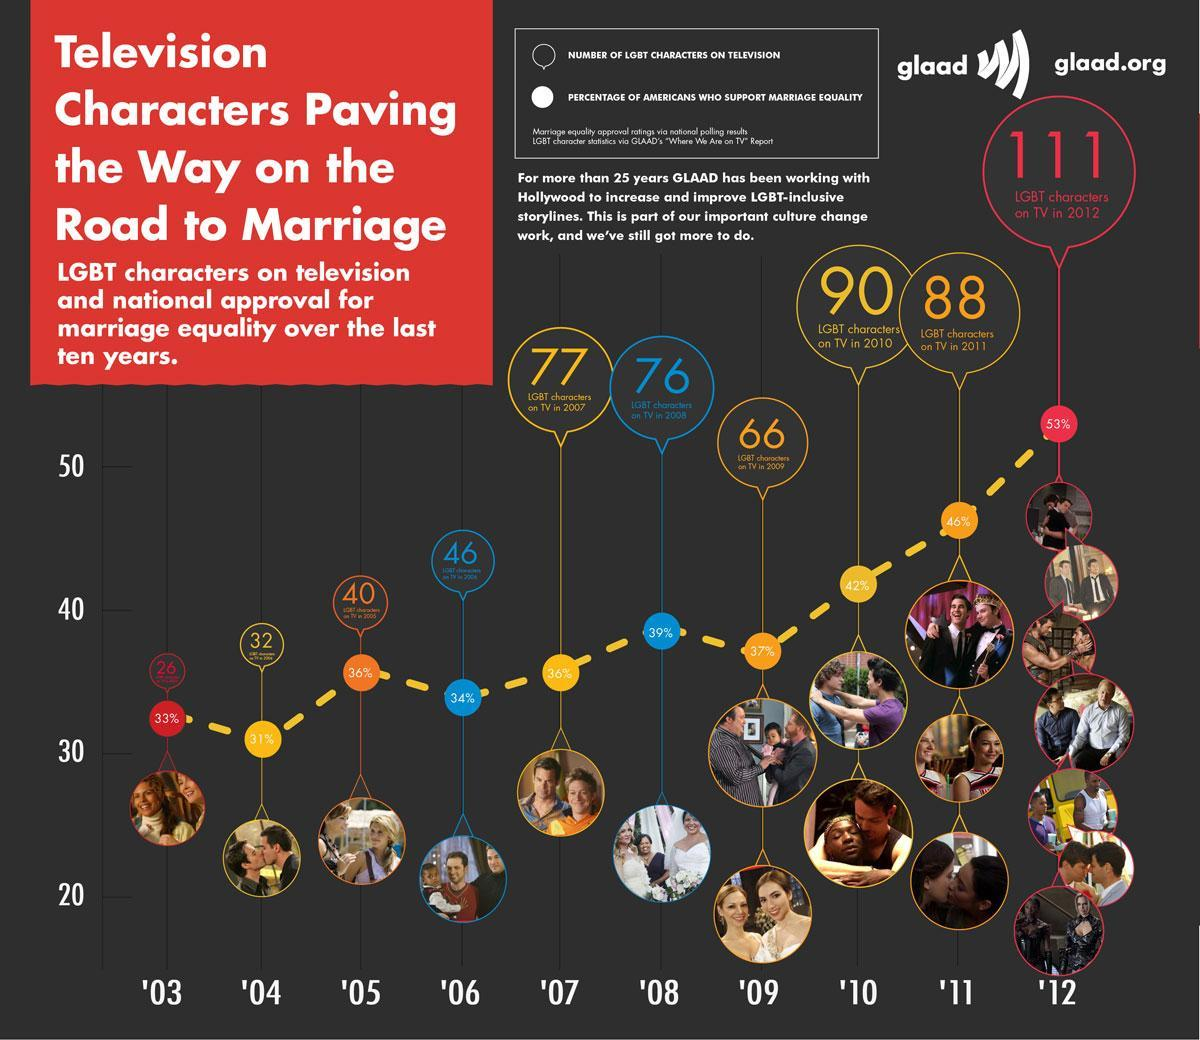How many LGBT couples are shown under the year 2011?
Answer the question with a short phrase. 3 How many LGBT characters were shown on TV in '09? 66 What percent of characters shown were gay on TV in '05? 36% 